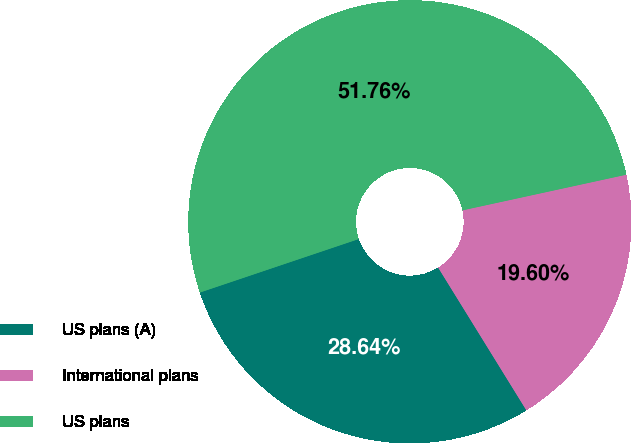<chart> <loc_0><loc_0><loc_500><loc_500><pie_chart><fcel>US plans (A)<fcel>International plans<fcel>US plans<nl><fcel>28.64%<fcel>19.6%<fcel>51.76%<nl></chart> 